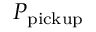<formula> <loc_0><loc_0><loc_500><loc_500>P _ { p i c k u p }</formula> 